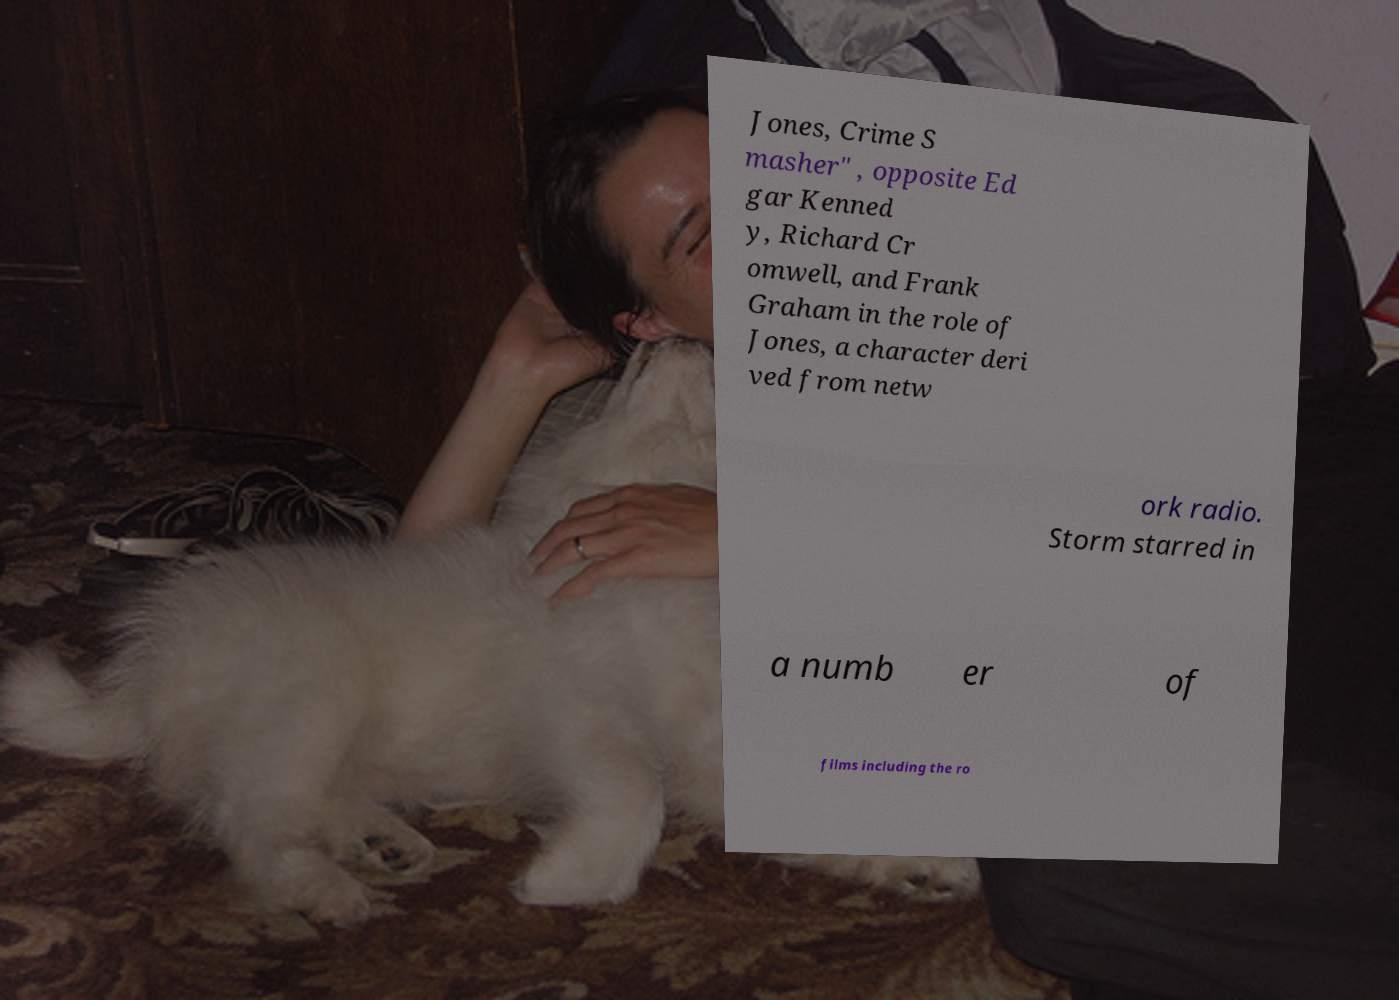Please read and relay the text visible in this image. What does it say? Jones, Crime S masher" , opposite Ed gar Kenned y, Richard Cr omwell, and Frank Graham in the role of Jones, a character deri ved from netw ork radio. Storm starred in a numb er of films including the ro 